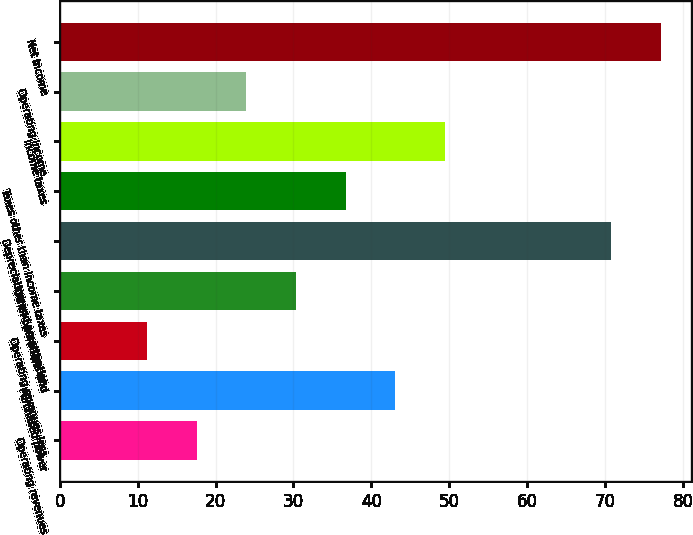Convert chart. <chart><loc_0><loc_0><loc_500><loc_500><bar_chart><fcel>Operating revenues<fcel>Purchased power<fcel>Operating revenues less<fcel>Other operations and<fcel>Depreciation and amortization<fcel>Taxes other than income taxes<fcel>Income taxes<fcel>Operating income<fcel>Net income<nl><fcel>17.58<fcel>43.1<fcel>11.2<fcel>30.34<fcel>70.8<fcel>36.72<fcel>49.48<fcel>23.96<fcel>77.18<nl></chart> 